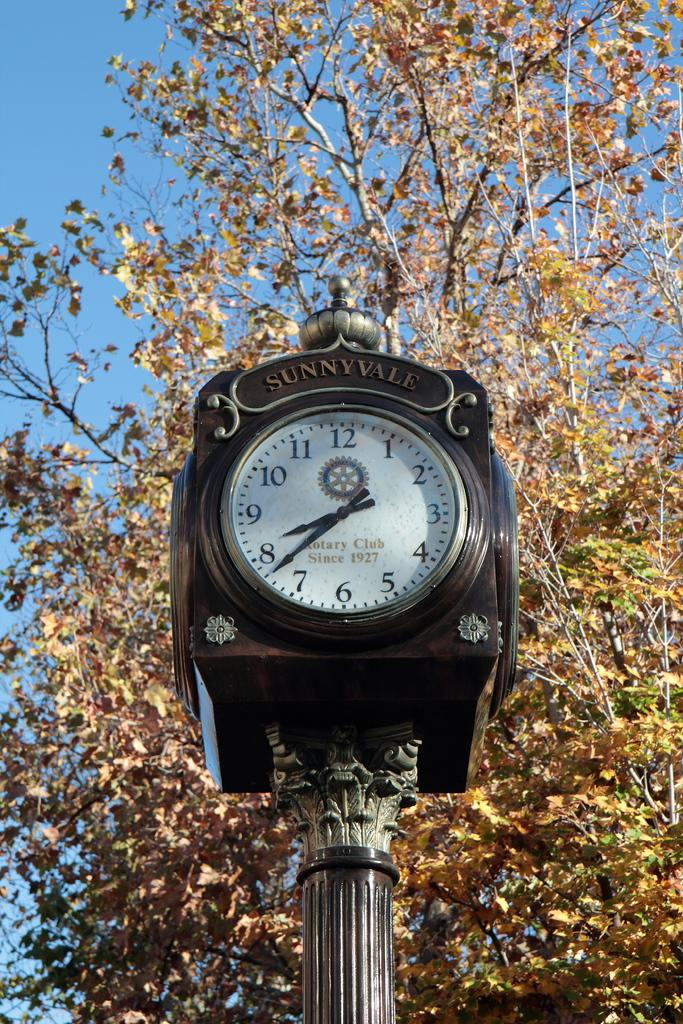<image>
Render a clear and concise summary of the photo. Large black clock that says SUNNYVALE on the top. 